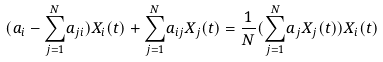Convert formula to latex. <formula><loc_0><loc_0><loc_500><loc_500>( a _ { i } - { \sum _ { j = 1 } ^ { N } } a _ { j i } ) X _ { i } ( t ) + { \sum _ { j = 1 } ^ { N } } a _ { i j } X _ { j } ( t ) = \frac { 1 } { N } ( { \sum _ { j = 1 } ^ { N } } a _ { j } X _ { j } ( t ) ) X _ { i } ( t )</formula> 